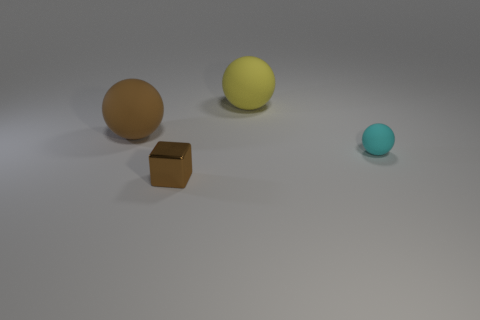Subtract all small rubber spheres. How many spheres are left? 2 Subtract all yellow balls. How many balls are left? 2 Add 4 cyan cylinders. How many objects exist? 8 Subtract 1 blocks. How many blocks are left? 0 Subtract all blocks. How many objects are left? 3 Subtract all green balls. Subtract all purple cylinders. How many balls are left? 3 Subtract all brown metallic objects. Subtract all brown objects. How many objects are left? 1 Add 2 metal blocks. How many metal blocks are left? 3 Add 1 matte things. How many matte things exist? 4 Subtract 0 purple cylinders. How many objects are left? 4 